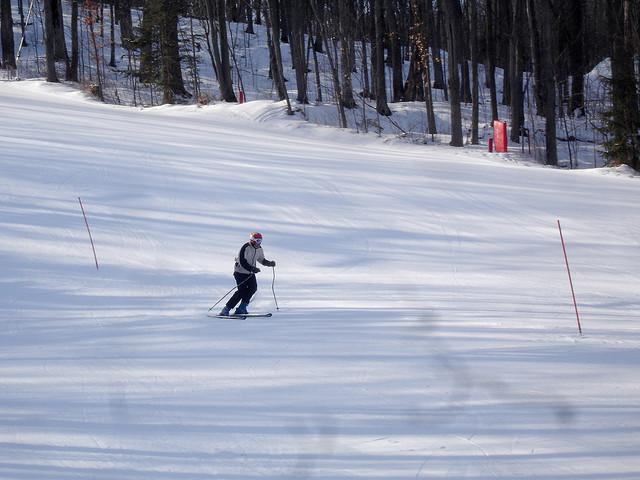Are there trees in the background?
Give a very brief answer. Yes. Are these pine trees?
Concise answer only. Yes. Is there a high probability that the man will collide with another skier?
Concise answer only. No. Why are there sticks in the snow?
Be succinct. Race markers. 